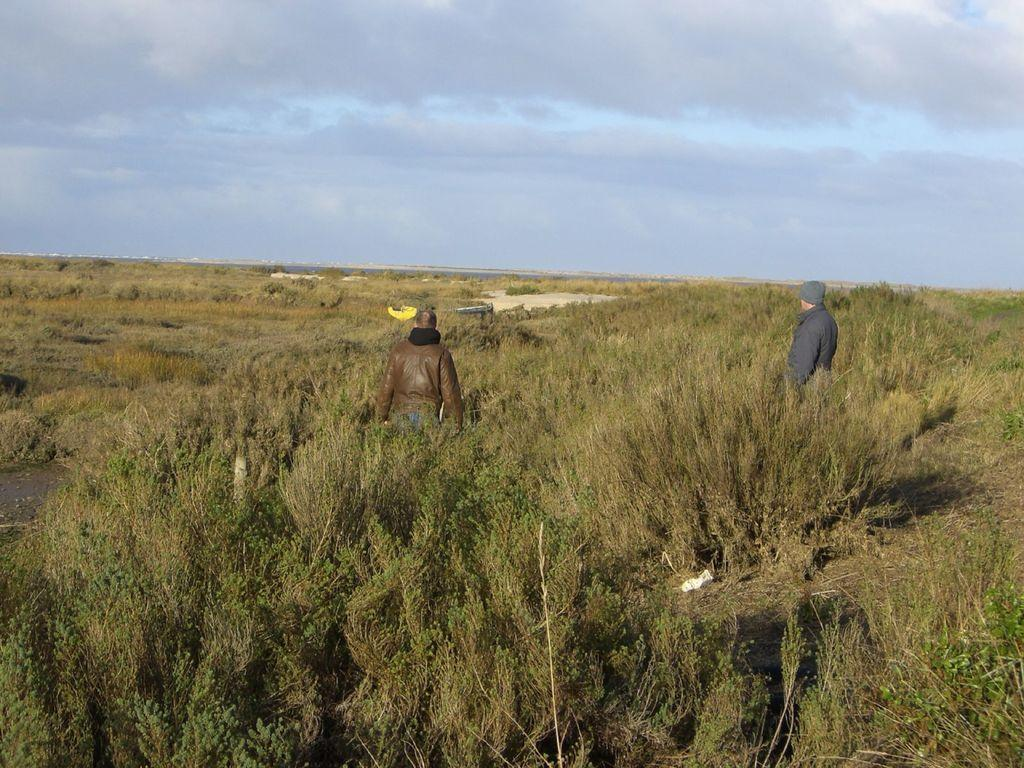How many people are in the image? There are two people in the image. What colors are the people wearing? The people are wearing brown, black, and grey color dresses. Where are the people standing in the image? The people are standing among plants. What can be seen in the background of the image? There are clouds and the sky visible in the background of the image. What type of paint is being used by the people in the image? There is no indication in the image that the people are using paint, so it cannot be determined from the picture. 